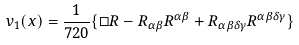<formula> <loc_0><loc_0><loc_500><loc_500>v _ { 1 } ( x ) = \frac { 1 } { 7 2 0 } \{ \Box R - R _ { \alpha \beta } R ^ { \alpha \beta } + R _ { \alpha \beta \delta \gamma } R ^ { \alpha \beta \delta \gamma } \}</formula> 